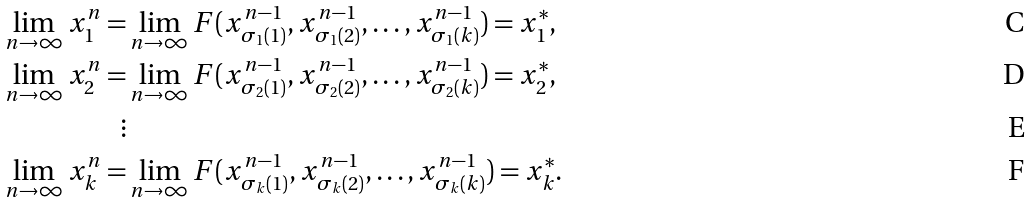Convert formula to latex. <formula><loc_0><loc_0><loc_500><loc_500>\lim _ { n \rightarrow \infty } x ^ { n } _ { 1 } = & \lim _ { n \rightarrow \infty } F ( x ^ { n - 1 } _ { \sigma _ { 1 } ( 1 ) } , x ^ { n - 1 } _ { \sigma _ { 1 } ( 2 ) } , \dots , x ^ { n - 1 } _ { \sigma _ { 1 } ( k ) } ) = x ^ { * } _ { 1 } , \\ \lim _ { n \rightarrow \infty } x ^ { n } _ { 2 } = & \lim _ { n \rightarrow \infty } F ( x ^ { n - 1 } _ { \sigma _ { 2 } ( 1 ) } , x ^ { n - 1 } _ { \sigma _ { 2 } ( 2 ) } , \dots , x ^ { n - 1 } _ { \sigma _ { 2 } ( k ) } ) = x ^ { * } _ { 2 } , \\ \vdots & \\ \lim _ { n \rightarrow \infty } x ^ { n } _ { k } = & \lim _ { n \rightarrow \infty } F ( x ^ { n - 1 } _ { \sigma _ { k } ( 1 ) } , x ^ { n - 1 } _ { \sigma _ { k } ( 2 ) } , \dots , x ^ { n - 1 } _ { \sigma _ { k } ( k ) } ) = x ^ { * } _ { k } .</formula> 